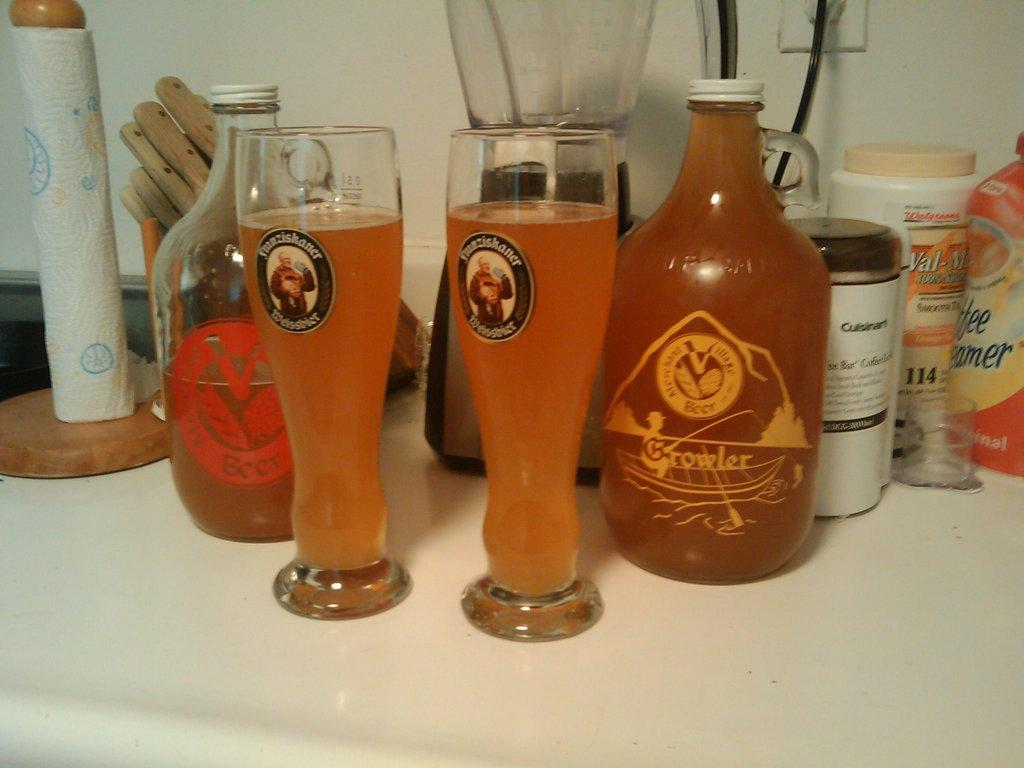What can be seen in the center of the image? There are two glasses with drinks in the center of the image. Where are the bottles located in the image? There are bottles on both the right and left sides of the image. What object is located at the back of the image? There is a grinder at the back of the image. What type of bird can be seen perched on the grinder in the image? There are no birds present in the image; it only features glasses with drinks, bottles, and a grinder. 